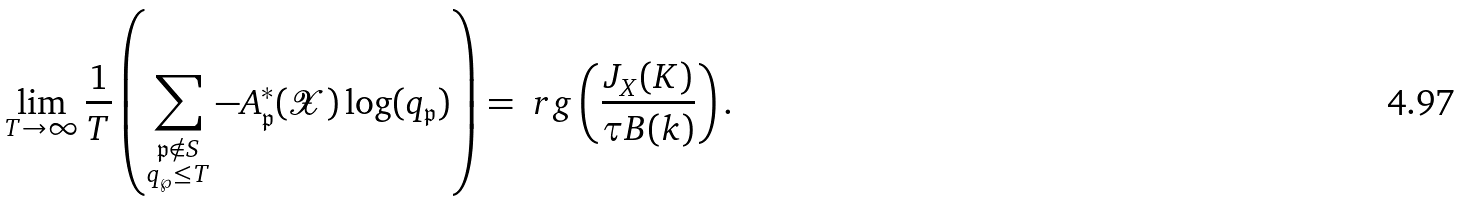Convert formula to latex. <formula><loc_0><loc_0><loc_500><loc_500>\lim _ { T \to \infty } \frac { 1 } { T } \left ( \sum _ { \substack { \mathfrak { p } \notin S \\ q _ { \wp } \leq T } } - A _ { \mathfrak { p } } ^ { * } ( \mathcal { X } ) \log ( q _ { \mathfrak { p } } ) \right ) = \ r g \left ( \frac { J _ { X } ( K ) } { \tau B ( k ) } \right ) .</formula> 